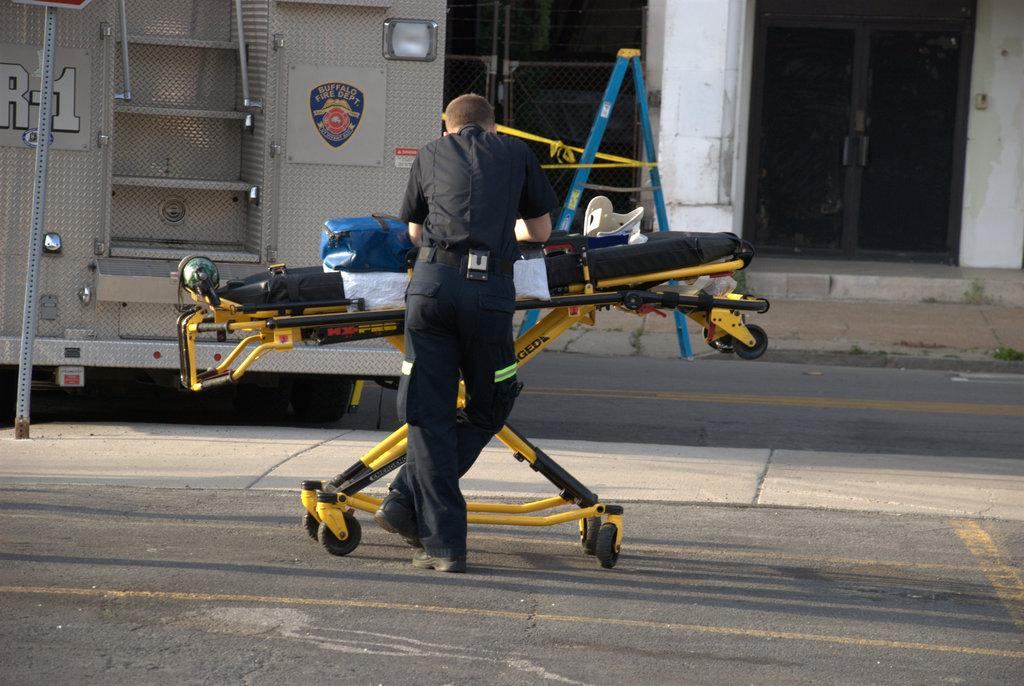What is the primary subject in the image? There is a man standing in the image. Where is the man located in the image? The man is standing on the ground. What can be seen in the background of the image? There are objects visible in the background of the image. What type of humor can be seen in the man's expression in the image? There is no indication of the man's expression or any humor in the image, as the provided facts do not mention these details. 